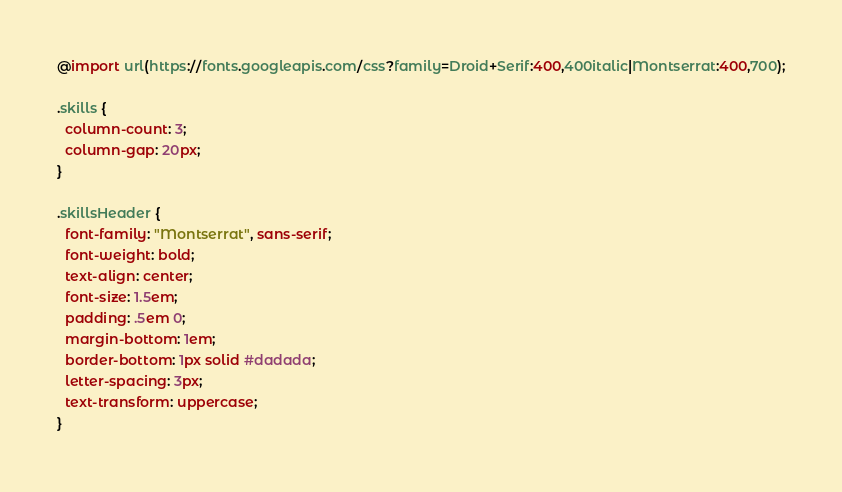<code> <loc_0><loc_0><loc_500><loc_500><_CSS_>@import url(https://fonts.googleapis.com/css?family=Droid+Serif:400,400italic|Montserrat:400,700);

.skills {
  column-count: 3;
  column-gap: 20px;
}

.skillsHeader {
  font-family: "Montserrat", sans-serif;
  font-weight: bold;
  text-align: center;
  font-size: 1.5em;
  padding: .5em 0;
  margin-bottom: 1em;
  border-bottom: 1px solid #dadada;
  letter-spacing: 3px;
  text-transform: uppercase;
}</code> 